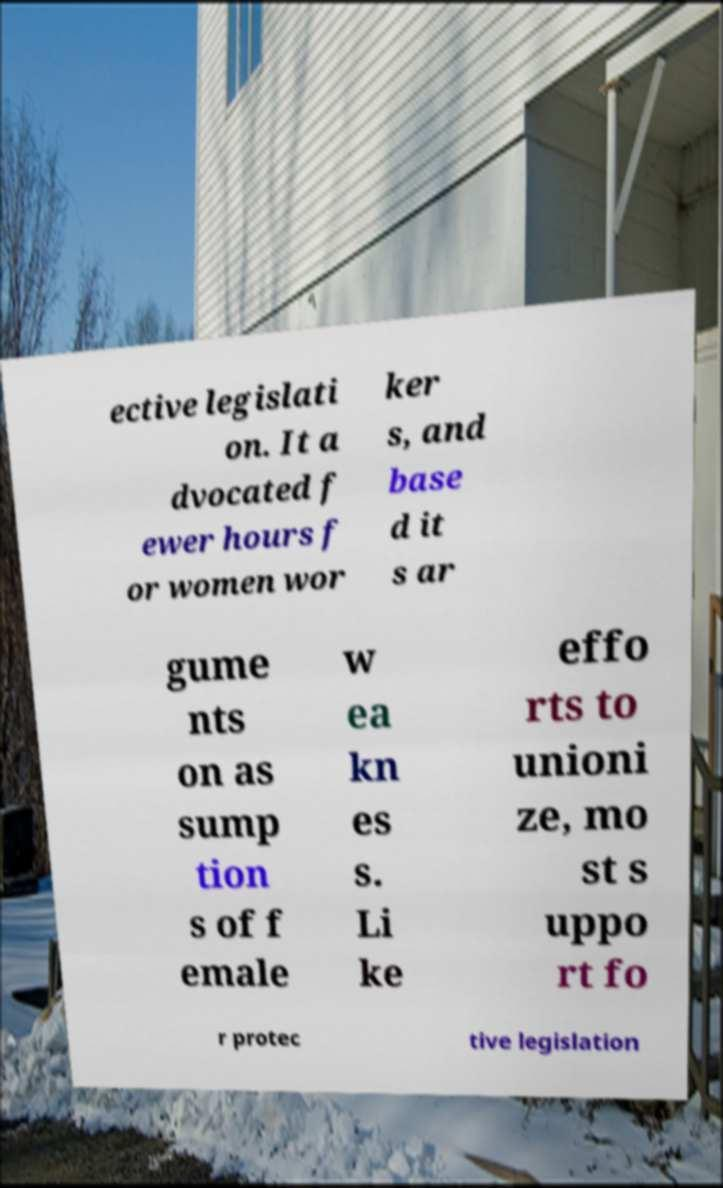For documentation purposes, I need the text within this image transcribed. Could you provide that? ective legislati on. It a dvocated f ewer hours f or women wor ker s, and base d it s ar gume nts on as sump tion s of f emale w ea kn es s. Li ke effo rts to unioni ze, mo st s uppo rt fo r protec tive legislation 